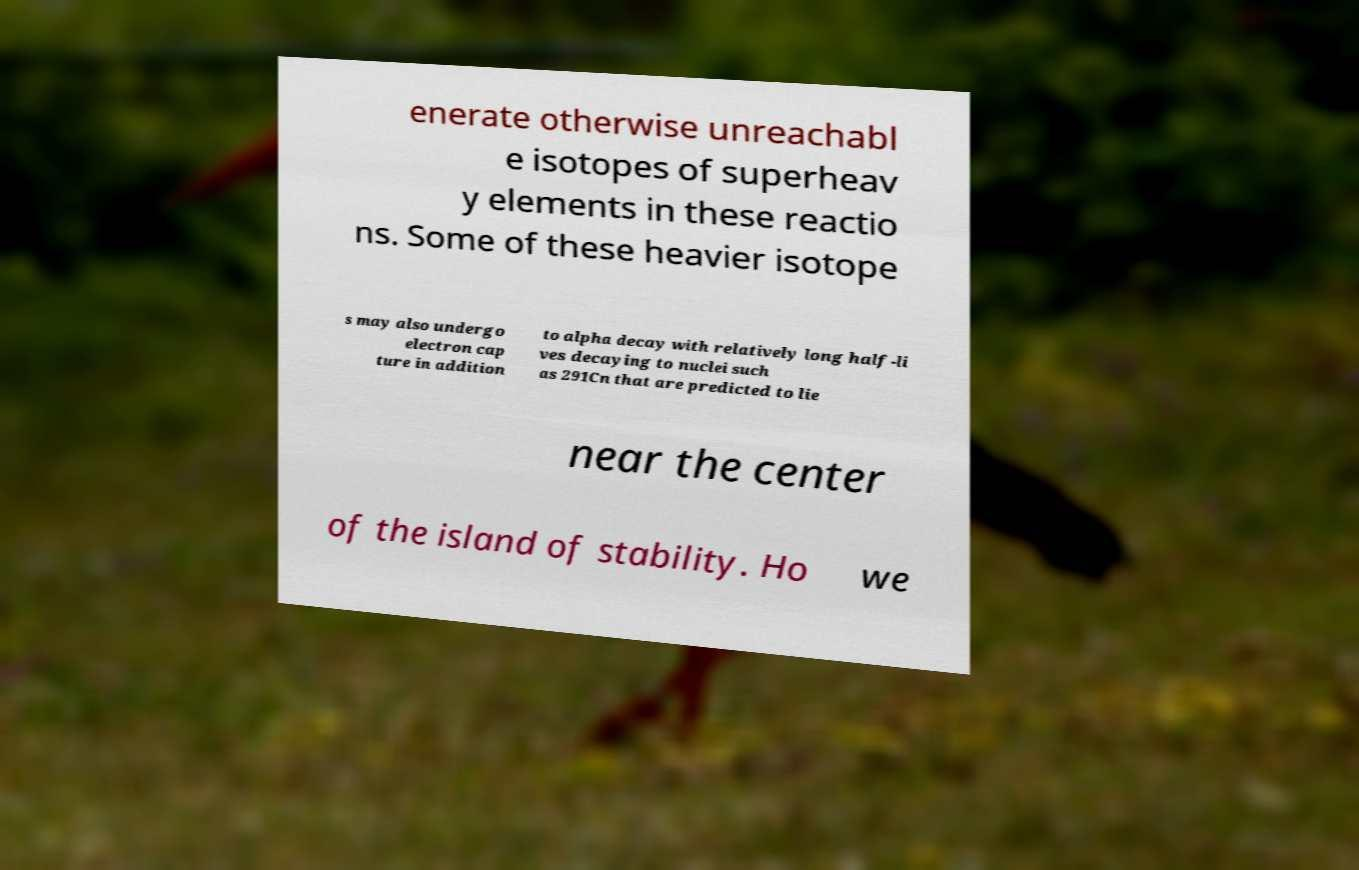There's text embedded in this image that I need extracted. Can you transcribe it verbatim? enerate otherwise unreachabl e isotopes of superheav y elements in these reactio ns. Some of these heavier isotope s may also undergo electron cap ture in addition to alpha decay with relatively long half-li ves decaying to nuclei such as 291Cn that are predicted to lie near the center of the island of stability. Ho we 